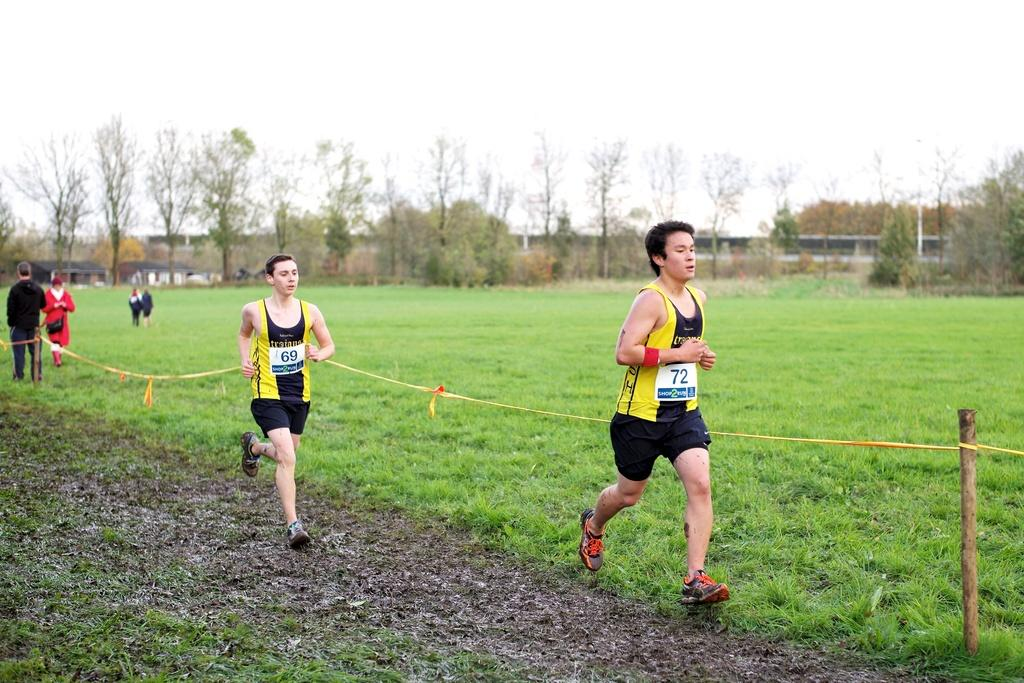<image>
Create a compact narrative representing the image presented. Runner wearing number 72 in front of the others. 